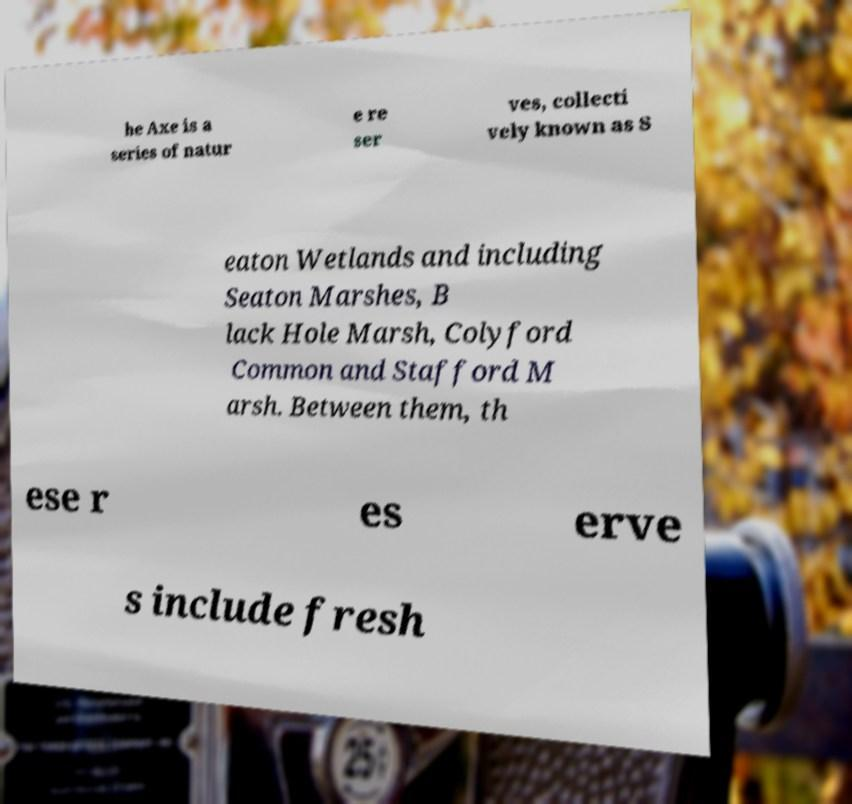Can you read and provide the text displayed in the image?This photo seems to have some interesting text. Can you extract and type it out for me? he Axe is a series of natur e re ser ves, collecti vely known as S eaton Wetlands and including Seaton Marshes, B lack Hole Marsh, Colyford Common and Stafford M arsh. Between them, th ese r es erve s include fresh 